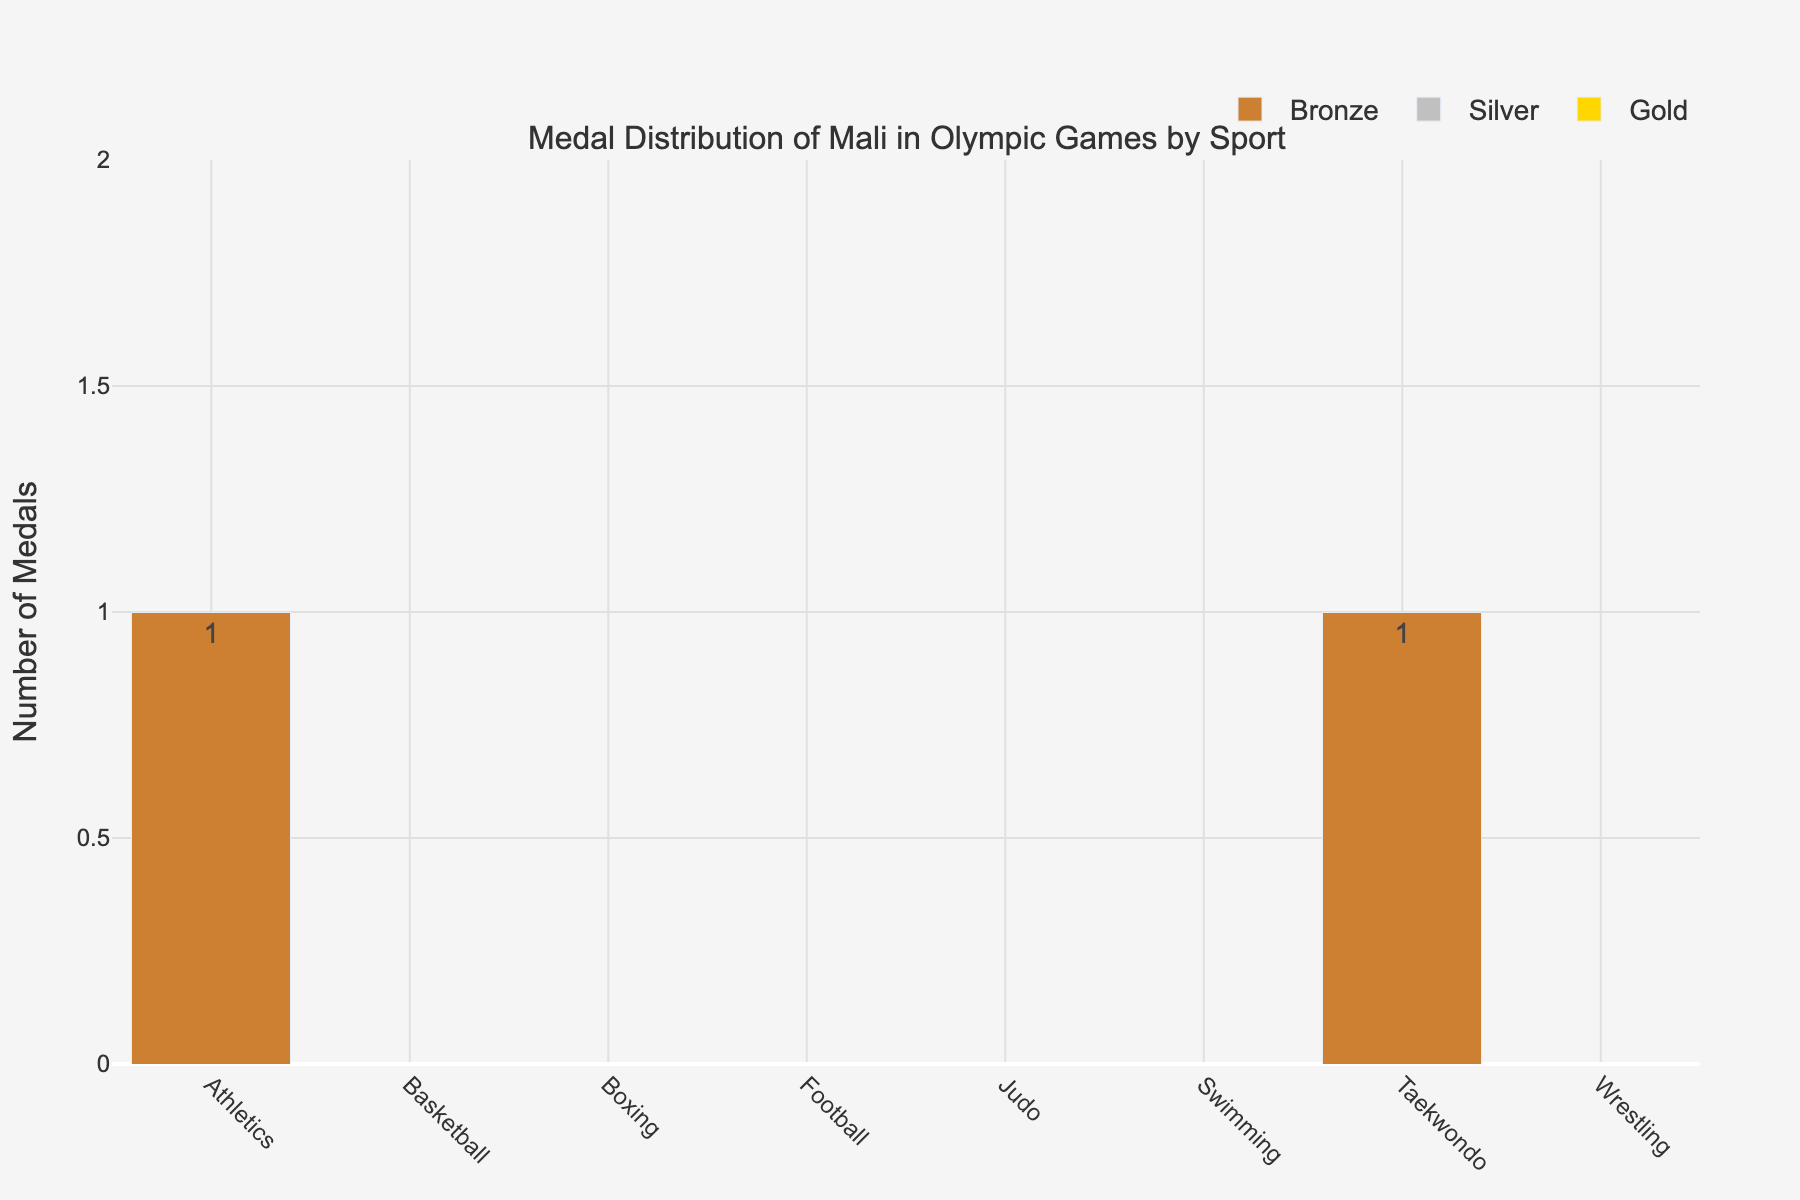How many total Bronze medals has Mali won in the sports shown? Sum up the Bronze medals across all the sports. They are 1 (Athletics) + 1 (Taekwondo) = 2
Answer: 2 Has Mali won any Gold or Silver medals? Look at the bars representing Gold and Silver medals for all sports. All these bars are zero in height.
Answer: No Which sport has the highest total number of medals? Compare the Total medal bars of all sports. Athletics and Taekwondo each have the highest, with 1 total medal.
Answer: Athletics, Taekwondo What is the total number of medals won by Mali in Athletics and Taekwondo combined? Athletics has 1 medal and Taekwondo has 1 medal. Adding them gives 1 + 1 = 2
Answer: 2 In which sports has Mali won exactly one medal? Look at the Total medal bars to determine the sports with exactly one medal. These sports are Athletics and Taekwondo.
Answer: Athletics, Taekwondo Which visual attribute indicates the type of medal won? The color of the bars represents the type of medal: gold for Gold medals, silver for Silver medals, and bronze for Bronze medals.
Answer: Color How many sports have no medals at all? Count the number of sports where the Total medal bar is zero. These sports are Basketball, Boxing, Football, Judo, Swimming, and Wrestling, making it 6 sports.
Answer: 6 Compare the number of medals in Athletics to the number of medals in all other sports combined. Athletics has 1 medal. The total number of medals in other sports combined is 1 (Taekwondo), making it Athletics: 1, Other sports: 1.
Answer: Athletics: 1, Other sports: 1 Is there any sport in which Mali has won both a Gold and a Silver medal? Check the bars for each sport to see if any sport has both Gold and Silver medal bars greater than zero.
Answer: No What percentage of the total medals won by Mali are Bronze medals? Mali has won 2 Bronze medals out of a total of 2 medals. The percentage is (2/2) * 100% = 100%
Answer: 100% 